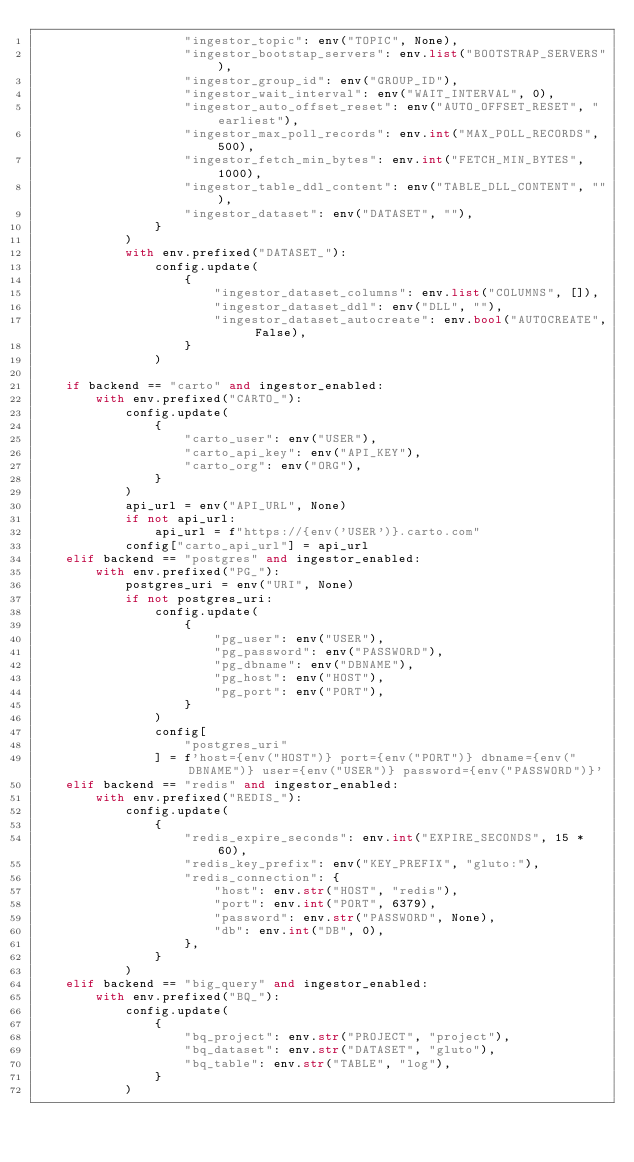<code> <loc_0><loc_0><loc_500><loc_500><_Python_>                    "ingestor_topic": env("TOPIC", None),
                    "ingestor_bootstap_servers": env.list("BOOTSTRAP_SERVERS"),
                    "ingestor_group_id": env("GROUP_ID"),
                    "ingestor_wait_interval": env("WAIT_INTERVAL", 0),
                    "ingestor_auto_offset_reset": env("AUTO_OFFSET_RESET", "earliest"),
                    "ingestor_max_poll_records": env.int("MAX_POLL_RECORDS", 500),
                    "ingestor_fetch_min_bytes": env.int("FETCH_MIN_BYTES", 1000),
                    "ingestor_table_ddl_content": env("TABLE_DLL_CONTENT", ""),
                    "ingestor_dataset": env("DATASET", ""),
                }
            )
            with env.prefixed("DATASET_"):
                config.update(
                    {
                        "ingestor_dataset_columns": env.list("COLUMNS", []),
                        "ingestor_dataset_ddl": env("DLL", ""),
                        "ingestor_dataset_autocreate": env.bool("AUTOCREATE", False),
                    }
                )

    if backend == "carto" and ingestor_enabled:
        with env.prefixed("CARTO_"):
            config.update(
                {
                    "carto_user": env("USER"),
                    "carto_api_key": env("API_KEY"),
                    "carto_org": env("ORG"),
                }
            )
            api_url = env("API_URL", None)
            if not api_url:
                api_url = f"https://{env('USER')}.carto.com"
            config["carto_api_url"] = api_url
    elif backend == "postgres" and ingestor_enabled:
        with env.prefixed("PG_"):
            postgres_uri = env("URI", None)
            if not postgres_uri:
                config.update(
                    {
                        "pg_user": env("USER"),
                        "pg_password": env("PASSWORD"),
                        "pg_dbname": env("DBNAME"),
                        "pg_host": env("HOST"),
                        "pg_port": env("PORT"),
                    }
                )
                config[
                    "postgres_uri"
                ] = f'host={env("HOST")} port={env("PORT")} dbname={env("DBNAME")} user={env("USER")} password={env("PASSWORD")}'
    elif backend == "redis" and ingestor_enabled:
        with env.prefixed("REDIS_"):
            config.update(
                {
                    "redis_expire_seconds": env.int("EXPIRE_SECONDS", 15 * 60),
                    "redis_key_prefix": env("KEY_PREFIX", "gluto:"),
                    "redis_connection": {
                        "host": env.str("HOST", "redis"),
                        "port": env.int("PORT", 6379),
                        "password": env.str("PASSWORD", None),
                        "db": env.int("DB", 0),
                    },
                }
            )
    elif backend == "big_query" and ingestor_enabled:
        with env.prefixed("BQ_"):
            config.update(
                {
                    "bq_project": env.str("PROJECT", "project"),
                    "bq_dataset": env.str("DATASET", "gluto"),
                    "bq_table": env.str("TABLE", "log"),
                }
            )
</code> 